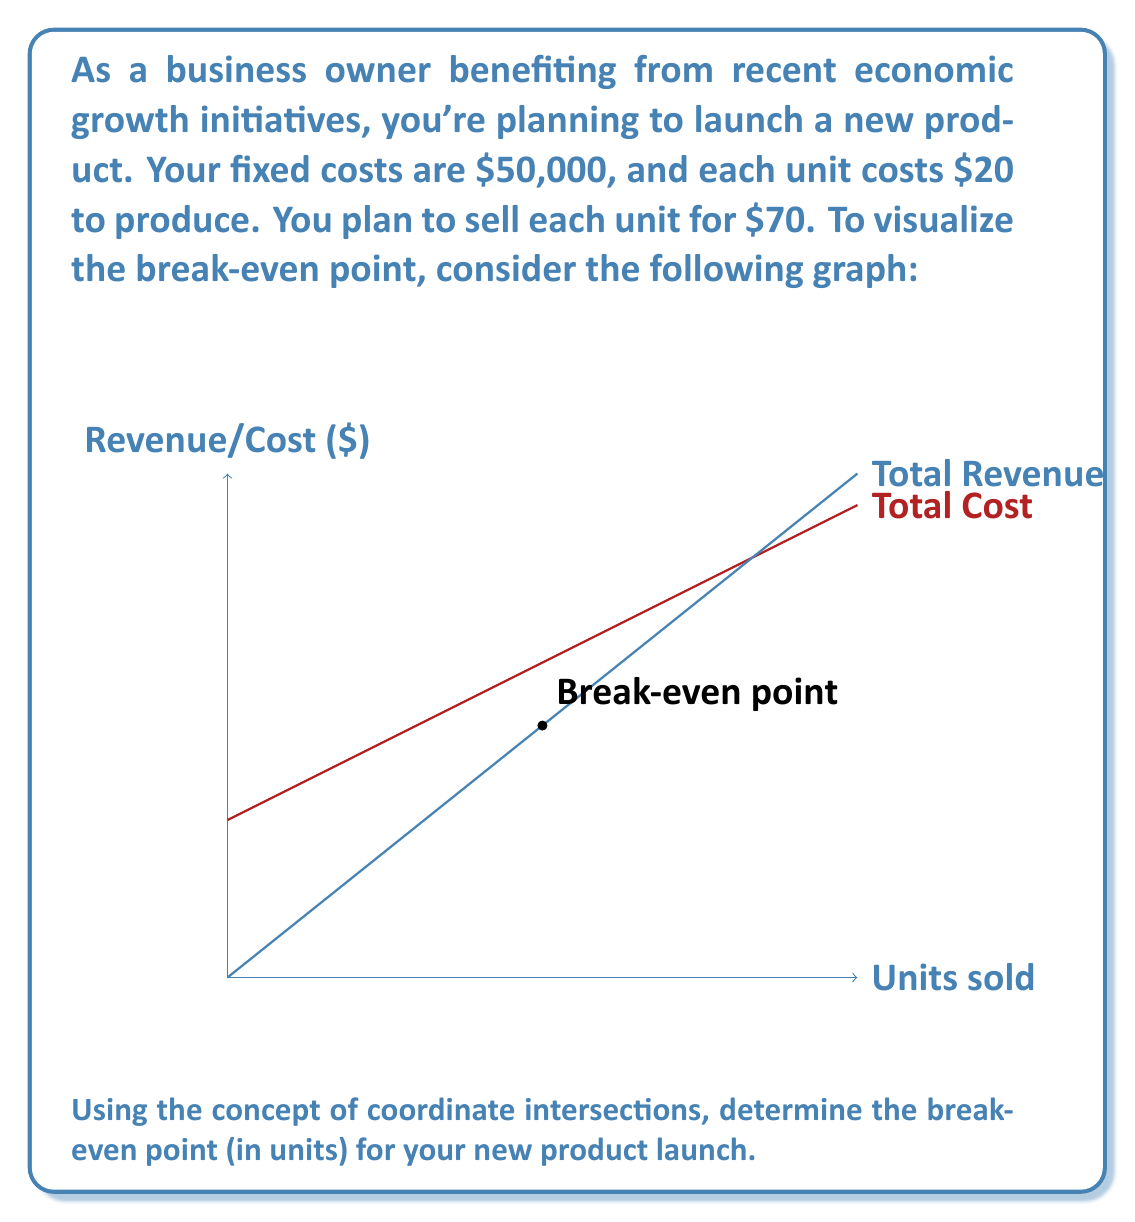Teach me how to tackle this problem. To find the break-even point, we need to determine where the total cost equals the total revenue. Let's approach this step-by-step:

1) Let $x$ be the number of units sold.

2) Total Cost (TC) equation:
   $TC = 50000 + 20x$
   
3) Total Revenue (TR) equation:
   $TR = 70x$

4) At the break-even point, TC = TR:
   $50000 + 20x = 70x$

5) Solve the equation:
   $50000 = 70x - 20x$
   $50000 = 50x$

6) Divide both sides by 50:
   $1000 = x$

Therefore, the break-even point occurs when 1000 units are sold.

To verify:
At 1000 units:
TC = $50000 + 20(1000) = $70,000
TR = $70(1000) = $70,000

Indeed, TC = TR at 1000 units, confirming the break-even point.
Answer: 1000 units 